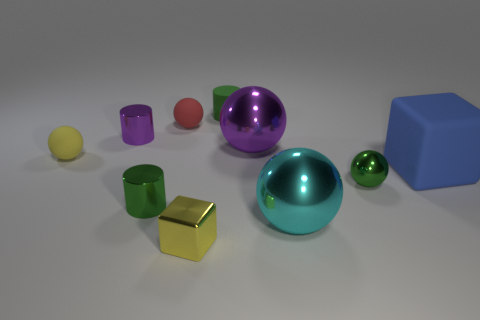Subtract all red blocks. How many green cylinders are left? 2 Subtract all big cyan balls. How many balls are left? 4 Subtract 1 balls. How many balls are left? 4 Subtract all green balls. How many balls are left? 4 Subtract all cylinders. How many objects are left? 7 Subtract all yellow spheres. Subtract all green cubes. How many spheres are left? 4 Subtract all matte cubes. Subtract all large blue things. How many objects are left? 8 Add 7 blue things. How many blue things are left? 8 Add 2 big blue rubber cylinders. How many big blue rubber cylinders exist? 2 Subtract 0 gray cylinders. How many objects are left? 10 